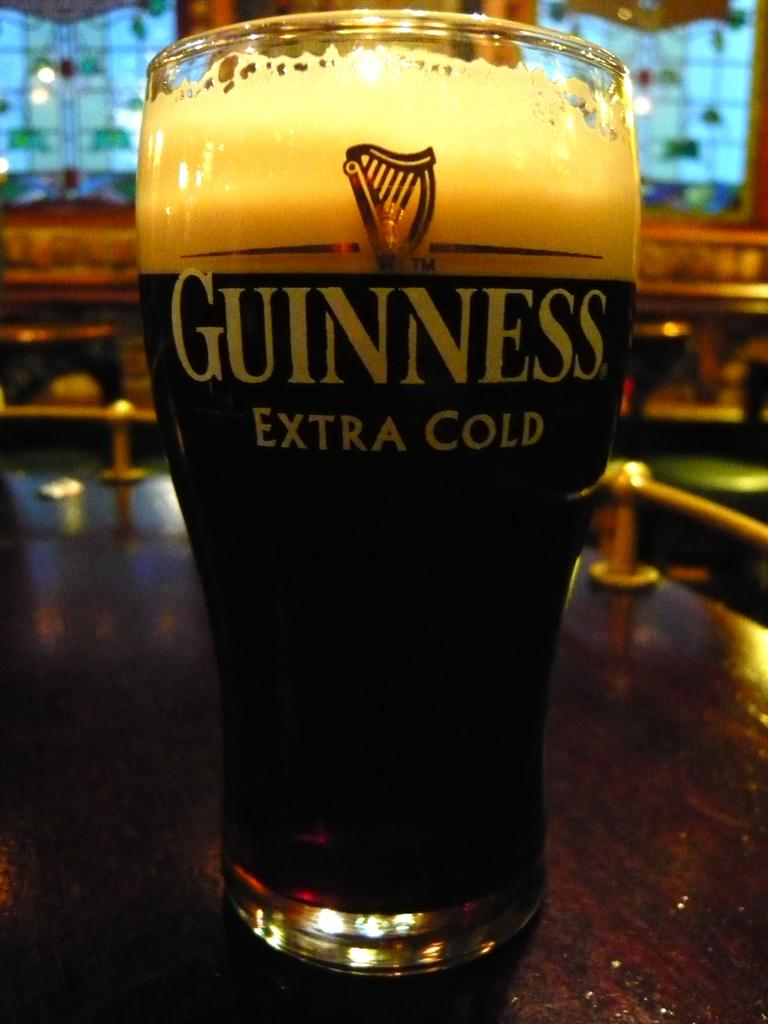Provide a one-sentence caption for the provided image. Cold glass of Guinness Extra Cold sitting on a wooden table. 